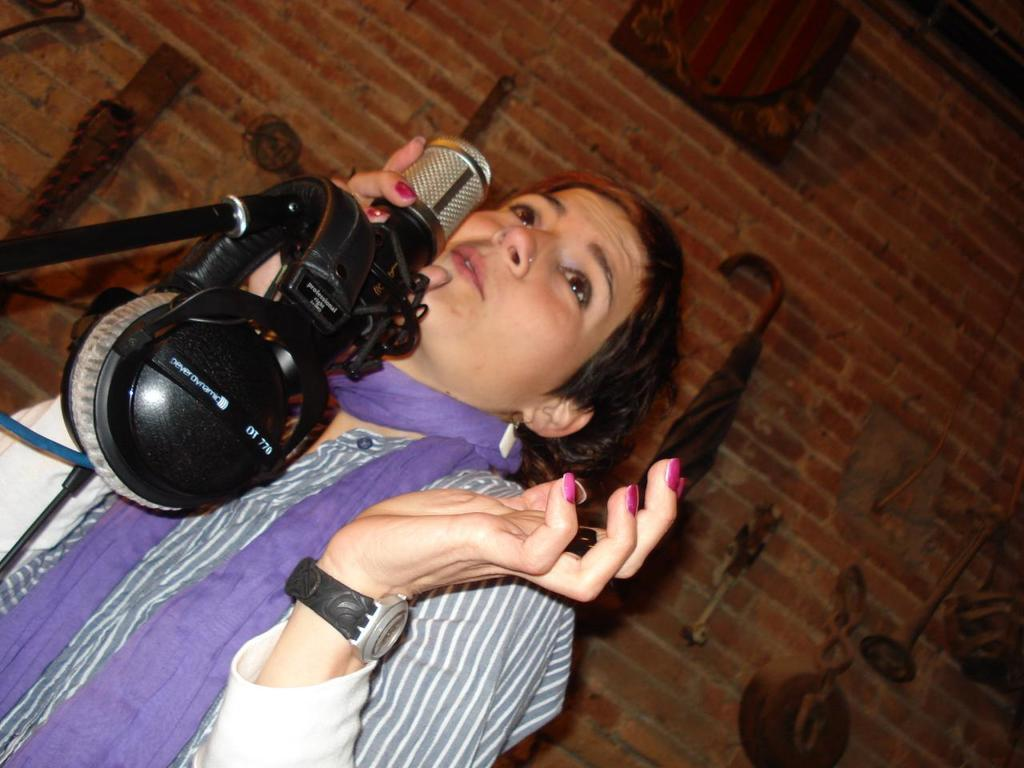Where was the image taken? The image is taken indoors. What can be seen in the background of the image? There is a wall with bricks in the background. Who is on the left side of the image? There is a woman on the left side of the image. What is the woman holding in her hand? The woman is holding a mic, which is a microphone. What type of army is present in the image? There is no army present in the image; it features a woman holding a microphone indoors. 